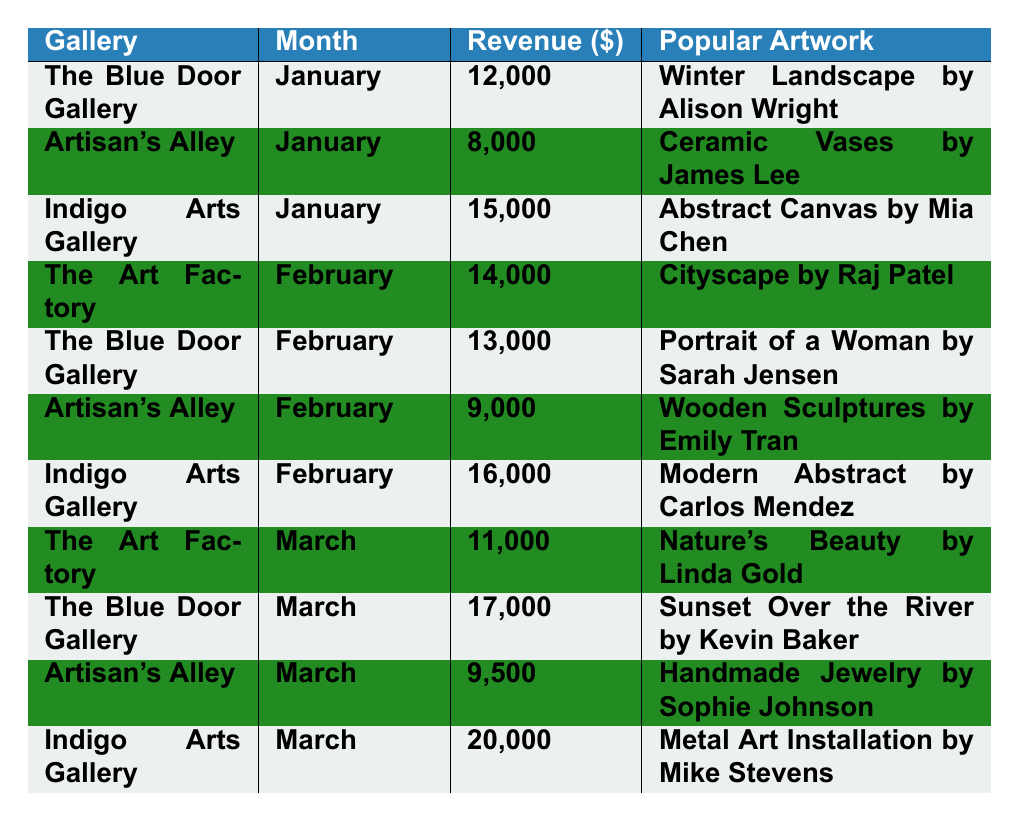What was the revenue of Indigo Arts Gallery in March? The table lists Indigo Arts Gallery's revenue for March as $20,000.
Answer: $20,000 Which gallery had the highest revenue in February? Comparing the revenues for all galleries in February, Indigo Arts Gallery had the highest revenue at $16,000.
Answer: Indigo Arts Gallery How much more revenue did The Blue Door Gallery make in March than Artisan's Alley? The Blue Door Gallery made $17,000 in March, while Artisan's Alley made $9,500. The difference is $17,000 - $9,500 = $7,500.
Answer: $7,500 What is the total revenue generated by Artisan's Alley from January to March? The revenues for Artisan's Alley are $8,000 (January), $9,000 (February), and $9,500 (March). Summing these gives $8,000 + $9,000 + $9,500 = $26,500.
Answer: $26,500 Was the popular artwork at The Art Factory in March Nature's Beauty? The table shows that the popular artwork at The Art Factory in March was "Nature's Beauty by Linda Gold." Therefore, this statement is true.
Answer: Yes Which gallery had the most popular artwork listed in January? For January, the artwork popular at Indigo Arts Gallery was "Abstract Canvas by Mia Chen," which had the highest revenue at $15,000 compared to others.
Answer: Indigo Arts Gallery What was the average revenue across all galleries in January? Adding the revenues for January: $12,000 (The Blue Door Gallery) + $8,000 (Artisan's Alley) + $15,000 (Indigo Arts Gallery) = $35,000. Since there are 3 galleries, the average is $35,000 / 3 = $11,666.67.
Answer: $11,666.67 Did Artisan's Alley show an increase in revenue from January to February? Artisan's Alley had $8,000 in January and $9,000 in February. Since $9,000 > $8,000, this indicates an increase.
Answer: Yes What is the difference in revenue between Indigo Arts Gallery in February and The Art Factory in March? Indigo Arts Gallery's revenue in February was $16,000, while The Art Factory's revenue in March was $11,000. The difference is $16,000 - $11,000 = $5,000.
Answer: $5,000 Which month had the highest total revenue across all galleries? Calculating total revenues: January ($12,000 + $8,000 + $15,000 = $35,000), February ($14,000 + $13,000 + $9,000 + $16,000 = $52,000), March ($11,000 + $17,000 + $9,500 + $20,000 = $57,500). March has the highest total revenue.
Answer: March 